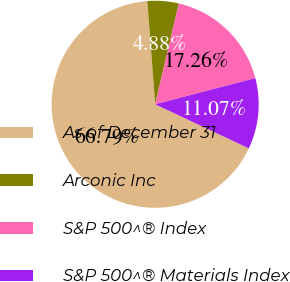Convert chart. <chart><loc_0><loc_0><loc_500><loc_500><pie_chart><fcel>As of December 31<fcel>Arconic Inc<fcel>S&P 500^® Index<fcel>S&P 500^® Materials Index<nl><fcel>66.78%<fcel>4.88%<fcel>17.26%<fcel>11.07%<nl></chart> 